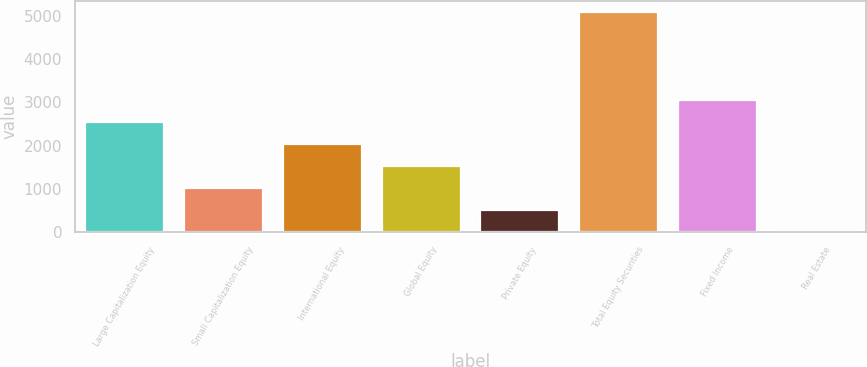Convert chart. <chart><loc_0><loc_0><loc_500><loc_500><bar_chart><fcel>Large Capitalization Equity<fcel>Small Capitalization Equity<fcel>International Equity<fcel>Global Equity<fcel>Private Equity<fcel>Total Equity Securities<fcel>Fixed Income<fcel>Real Estate<nl><fcel>2542.5<fcel>1023<fcel>2036<fcel>1529.5<fcel>516.5<fcel>5075<fcel>3049<fcel>10<nl></chart> 